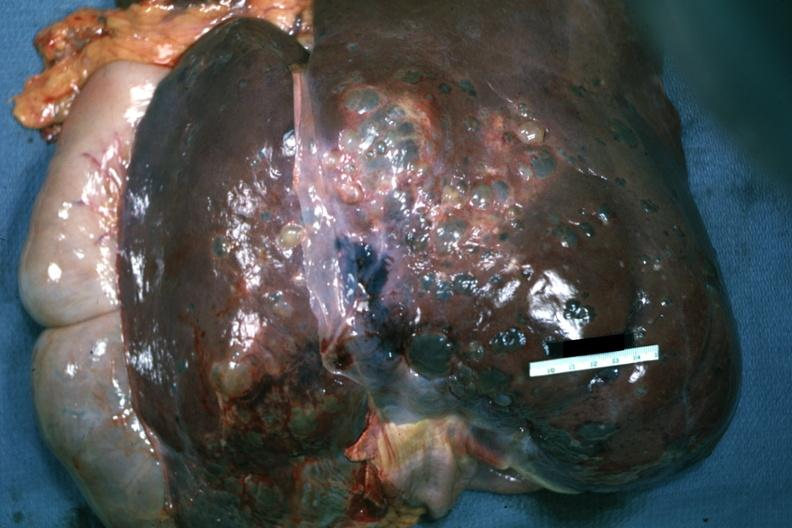does this image show anterior view of removed and non-sectioned liver as surgeon would see thcase of polycystic disease?
Answer the question using a single word or phrase. Yes 